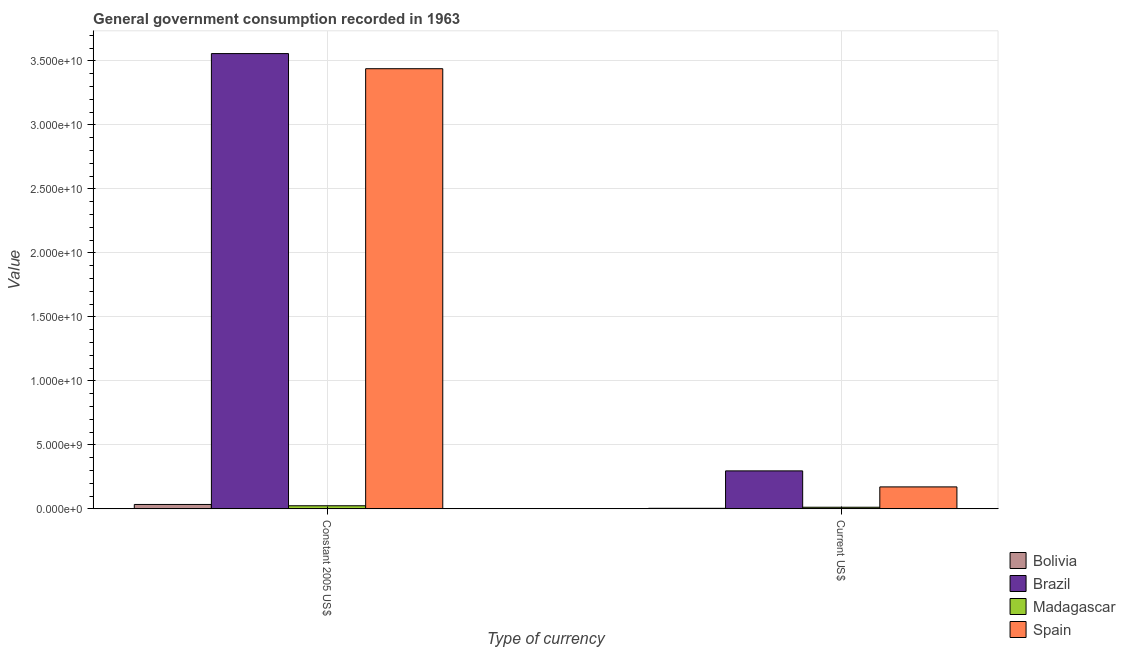How many different coloured bars are there?
Provide a short and direct response. 4. Are the number of bars per tick equal to the number of legend labels?
Make the answer very short. Yes. How many bars are there on the 2nd tick from the left?
Keep it short and to the point. 4. What is the label of the 2nd group of bars from the left?
Give a very brief answer. Current US$. What is the value consumed in constant 2005 us$ in Bolivia?
Offer a very short reply. 3.42e+08. Across all countries, what is the maximum value consumed in current us$?
Provide a succinct answer. 2.97e+09. Across all countries, what is the minimum value consumed in current us$?
Provide a short and direct response. 4.17e+07. What is the total value consumed in constant 2005 us$ in the graph?
Provide a short and direct response. 7.05e+1. What is the difference between the value consumed in constant 2005 us$ in Spain and that in Bolivia?
Your answer should be very brief. 3.40e+1. What is the difference between the value consumed in current us$ in Spain and the value consumed in constant 2005 us$ in Madagascar?
Provide a short and direct response. 1.47e+09. What is the average value consumed in constant 2005 us$ per country?
Offer a very short reply. 1.76e+1. What is the difference between the value consumed in constant 2005 us$ and value consumed in current us$ in Bolivia?
Offer a terse response. 3.01e+08. In how many countries, is the value consumed in constant 2005 us$ greater than 32000000000 ?
Your answer should be compact. 2. What is the ratio of the value consumed in current us$ in Brazil to that in Spain?
Give a very brief answer. 1.73. In how many countries, is the value consumed in current us$ greater than the average value consumed in current us$ taken over all countries?
Provide a succinct answer. 2. What does the 1st bar from the left in Current US$ represents?
Keep it short and to the point. Bolivia. How many bars are there?
Give a very brief answer. 8. Are all the bars in the graph horizontal?
Your answer should be compact. No. What is the difference between two consecutive major ticks on the Y-axis?
Your answer should be compact. 5.00e+09. Does the graph contain any zero values?
Provide a short and direct response. No. Where does the legend appear in the graph?
Make the answer very short. Bottom right. How many legend labels are there?
Keep it short and to the point. 4. How are the legend labels stacked?
Keep it short and to the point. Vertical. What is the title of the graph?
Provide a succinct answer. General government consumption recorded in 1963. Does "Timor-Leste" appear as one of the legend labels in the graph?
Give a very brief answer. No. What is the label or title of the X-axis?
Ensure brevity in your answer.  Type of currency. What is the label or title of the Y-axis?
Provide a short and direct response. Value. What is the Value of Bolivia in Constant 2005 US$?
Ensure brevity in your answer.  3.42e+08. What is the Value in Brazil in Constant 2005 US$?
Ensure brevity in your answer.  3.56e+1. What is the Value in Madagascar in Constant 2005 US$?
Provide a succinct answer. 2.41e+08. What is the Value of Spain in Constant 2005 US$?
Your response must be concise. 3.44e+1. What is the Value in Bolivia in Current US$?
Offer a very short reply. 4.17e+07. What is the Value of Brazil in Current US$?
Make the answer very short. 2.97e+09. What is the Value of Madagascar in Current US$?
Keep it short and to the point. 1.26e+08. What is the Value of Spain in Current US$?
Provide a short and direct response. 1.72e+09. Across all Type of currency, what is the maximum Value in Bolivia?
Offer a terse response. 3.42e+08. Across all Type of currency, what is the maximum Value in Brazil?
Provide a succinct answer. 3.56e+1. Across all Type of currency, what is the maximum Value of Madagascar?
Your response must be concise. 2.41e+08. Across all Type of currency, what is the maximum Value of Spain?
Your response must be concise. 3.44e+1. Across all Type of currency, what is the minimum Value of Bolivia?
Your answer should be compact. 4.17e+07. Across all Type of currency, what is the minimum Value in Brazil?
Give a very brief answer. 2.97e+09. Across all Type of currency, what is the minimum Value of Madagascar?
Offer a very short reply. 1.26e+08. Across all Type of currency, what is the minimum Value of Spain?
Your answer should be very brief. 1.72e+09. What is the total Value of Bolivia in the graph?
Ensure brevity in your answer.  3.84e+08. What is the total Value in Brazil in the graph?
Offer a terse response. 3.85e+1. What is the total Value in Madagascar in the graph?
Ensure brevity in your answer.  3.67e+08. What is the total Value in Spain in the graph?
Make the answer very short. 3.61e+1. What is the difference between the Value in Bolivia in Constant 2005 US$ and that in Current US$?
Provide a short and direct response. 3.01e+08. What is the difference between the Value of Brazil in Constant 2005 US$ and that in Current US$?
Give a very brief answer. 3.26e+1. What is the difference between the Value of Madagascar in Constant 2005 US$ and that in Current US$?
Ensure brevity in your answer.  1.15e+08. What is the difference between the Value of Spain in Constant 2005 US$ and that in Current US$?
Provide a short and direct response. 3.27e+1. What is the difference between the Value in Bolivia in Constant 2005 US$ and the Value in Brazil in Current US$?
Your answer should be compact. -2.62e+09. What is the difference between the Value in Bolivia in Constant 2005 US$ and the Value in Madagascar in Current US$?
Your response must be concise. 2.17e+08. What is the difference between the Value in Bolivia in Constant 2005 US$ and the Value in Spain in Current US$?
Offer a very short reply. -1.37e+09. What is the difference between the Value in Brazil in Constant 2005 US$ and the Value in Madagascar in Current US$?
Your response must be concise. 3.54e+1. What is the difference between the Value in Brazil in Constant 2005 US$ and the Value in Spain in Current US$?
Make the answer very short. 3.39e+1. What is the difference between the Value in Madagascar in Constant 2005 US$ and the Value in Spain in Current US$?
Ensure brevity in your answer.  -1.47e+09. What is the average Value in Bolivia per Type of currency?
Provide a short and direct response. 1.92e+08. What is the average Value in Brazil per Type of currency?
Keep it short and to the point. 1.93e+1. What is the average Value of Madagascar per Type of currency?
Provide a succinct answer. 1.83e+08. What is the average Value of Spain per Type of currency?
Your response must be concise. 1.81e+1. What is the difference between the Value of Bolivia and Value of Brazil in Constant 2005 US$?
Provide a short and direct response. -3.52e+1. What is the difference between the Value of Bolivia and Value of Madagascar in Constant 2005 US$?
Provide a succinct answer. 1.01e+08. What is the difference between the Value in Bolivia and Value in Spain in Constant 2005 US$?
Offer a very short reply. -3.40e+1. What is the difference between the Value of Brazil and Value of Madagascar in Constant 2005 US$?
Ensure brevity in your answer.  3.53e+1. What is the difference between the Value in Brazil and Value in Spain in Constant 2005 US$?
Offer a terse response. 1.18e+09. What is the difference between the Value in Madagascar and Value in Spain in Constant 2005 US$?
Offer a very short reply. -3.42e+1. What is the difference between the Value of Bolivia and Value of Brazil in Current US$?
Keep it short and to the point. -2.92e+09. What is the difference between the Value of Bolivia and Value of Madagascar in Current US$?
Your answer should be very brief. -8.38e+07. What is the difference between the Value of Bolivia and Value of Spain in Current US$?
Give a very brief answer. -1.67e+09. What is the difference between the Value in Brazil and Value in Madagascar in Current US$?
Your answer should be compact. 2.84e+09. What is the difference between the Value of Brazil and Value of Spain in Current US$?
Offer a terse response. 1.25e+09. What is the difference between the Value in Madagascar and Value in Spain in Current US$?
Offer a terse response. -1.59e+09. What is the ratio of the Value in Bolivia in Constant 2005 US$ to that in Current US$?
Offer a terse response. 8.2. What is the ratio of the Value in Brazil in Constant 2005 US$ to that in Current US$?
Offer a very short reply. 11.99. What is the ratio of the Value of Madagascar in Constant 2005 US$ to that in Current US$?
Make the answer very short. 1.92. What is the ratio of the Value in Spain in Constant 2005 US$ to that in Current US$?
Ensure brevity in your answer.  20.05. What is the difference between the highest and the second highest Value of Bolivia?
Make the answer very short. 3.01e+08. What is the difference between the highest and the second highest Value in Brazil?
Offer a terse response. 3.26e+1. What is the difference between the highest and the second highest Value in Madagascar?
Offer a very short reply. 1.15e+08. What is the difference between the highest and the second highest Value in Spain?
Keep it short and to the point. 3.27e+1. What is the difference between the highest and the lowest Value of Bolivia?
Offer a very short reply. 3.01e+08. What is the difference between the highest and the lowest Value of Brazil?
Your answer should be very brief. 3.26e+1. What is the difference between the highest and the lowest Value of Madagascar?
Make the answer very short. 1.15e+08. What is the difference between the highest and the lowest Value of Spain?
Keep it short and to the point. 3.27e+1. 